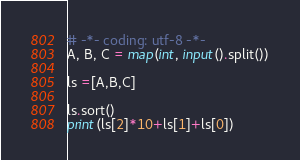Convert code to text. <code><loc_0><loc_0><loc_500><loc_500><_Python_># -*- coding: utf-8 -*-
A, B, C = map(int, input().split())

ls =[A,B,C]

ls.sort()
print(ls[2]*10+ls[1]+ls[0])
</code> 